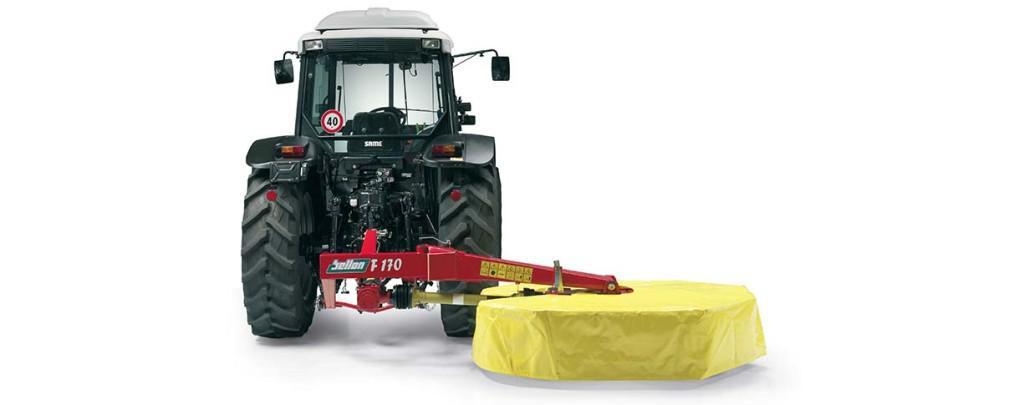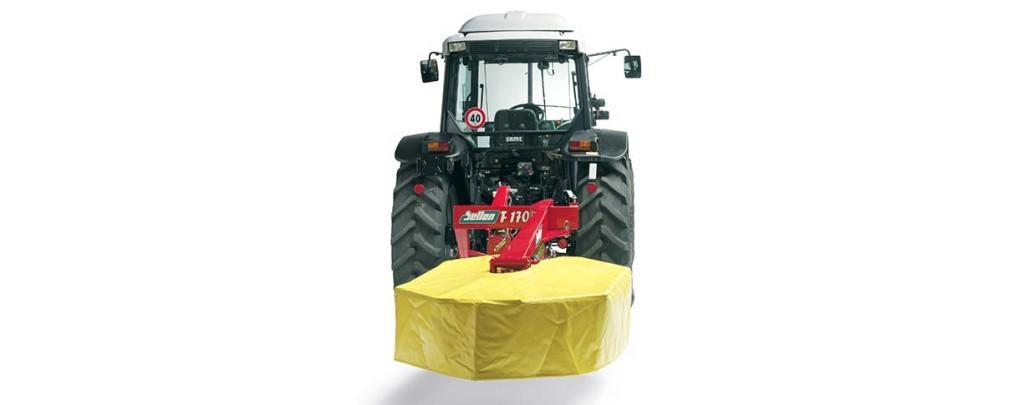The first image is the image on the left, the second image is the image on the right. Given the left and right images, does the statement "There is a shiny silver machine in one image, and something red/orange in the other." hold true? Answer yes or no. No. The first image is the image on the left, the second image is the image on the right. For the images displayed, is the sentence "There are more containers in the image on the right." factually correct? Answer yes or no. No. 